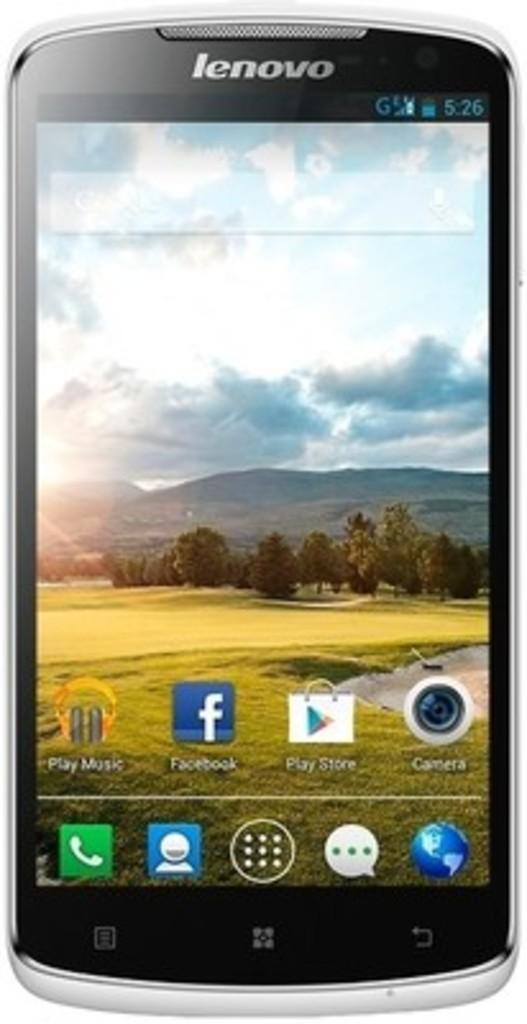<image>
Render a clear and concise summary of the photo. Lenovo smartphone with apps on its homepage like Facebook, Play music, and Play Store. 